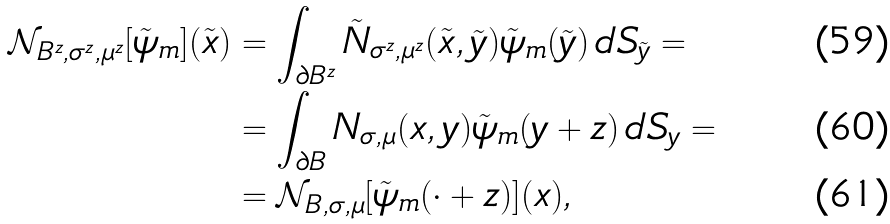Convert formula to latex. <formula><loc_0><loc_0><loc_500><loc_500>\mathcal { N } _ { B ^ { z } , \sigma ^ { z } , \mu ^ { z } } [ \tilde { \psi } _ { m } ] ( \tilde { x } ) & = \int _ { \partial B ^ { z } } \tilde { N } _ { \sigma ^ { z } , \mu ^ { z } } ( \tilde { x } , \tilde { y } ) \tilde { \psi } _ { m } ( \tilde { y } ) \, d S _ { \tilde { y } } = \\ & = \int _ { \partial B } N _ { \sigma , \mu } ( x , y ) \tilde { \psi } _ { m } ( y + z ) \, d S _ { y } = \\ & = \mathcal { N } _ { B , \sigma , \mu } [ \tilde { \psi } _ { m } ( \cdot + z ) ] ( x ) ,</formula> 